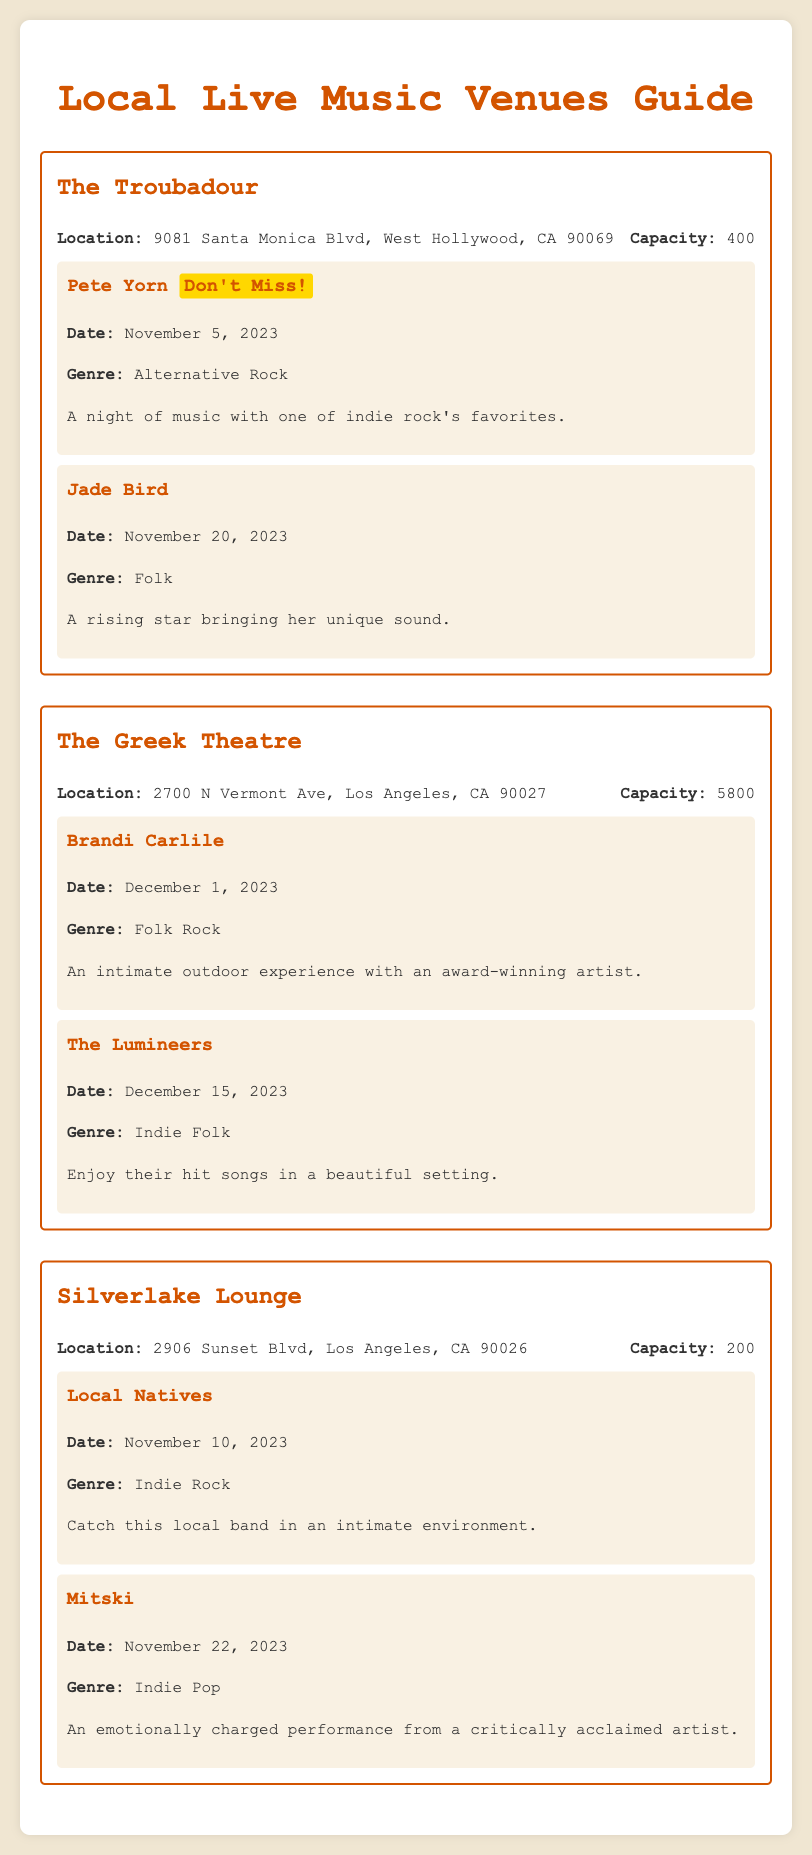What is the location of The Troubadour? The location is specified in the venue information section for The Troubadour.
Answer: 9081 Santa Monica Blvd, West Hollywood, CA 90069 What is the capacity of The Greek Theatre? The capacity is listed under the venue information for The Greek Theatre.
Answer: 5800 When is Pete Yorn performing? The date for Pete Yorn's performance is mentioned in the events section under The Troubadour.
Answer: November 5, 2023 Which genre is associated with Mitski's performance? The genre is stated in the event details for Mitski at Silverlake Lounge.
Answer: Indie Pop How many events are scheduled at Silverlake Lounge? The number of events is determined by counting the event listings under Silverlake Lounge.
Answer: 2 What is the date for Jade Bird's performance? The date is provided in the events section for Jade Bird at The Troubadour.
Answer: November 20, 2023 What kind of experience does Brandi Carlile's performance promise? This is inferred from the description of Brandi Carlile's event at The Greek Theatre.
Answer: An intimate outdoor experience What unique aspect might attract someone to the Local Natives concert? This is derived from the description for Local Natives' performance at Silverlake Lounge.
Answer: An intimate environment 